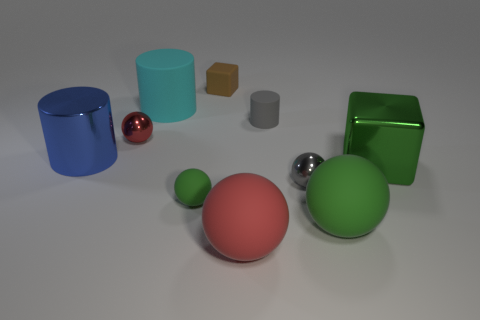What number of other objects are the same color as the rubber cube?
Make the answer very short. 0. Do the cube right of the gray shiny ball and the metal sphere that is behind the large blue object have the same size?
Provide a short and direct response. No. The large cylinder in front of the tiny red metal thing is what color?
Provide a short and direct response. Blue. Is the number of cyan matte objects on the right side of the small gray ball less than the number of large green things?
Provide a short and direct response. Yes. Are the tiny block and the big green block made of the same material?
Your answer should be compact. No. What is the size of the gray thing that is the same shape as the large blue metallic object?
Offer a terse response. Small. What number of things are either small metallic balls right of the tiny brown cube or rubber objects that are behind the large red object?
Offer a very short reply. 6. Is the number of big cyan cylinders less than the number of large yellow matte blocks?
Provide a short and direct response. No. Is the size of the red rubber object the same as the block that is right of the small matte cube?
Your response must be concise. Yes. What number of metal things are either cyan blocks or large balls?
Ensure brevity in your answer.  0. 